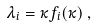<formula> <loc_0><loc_0><loc_500><loc_500>\lambda _ { i } = \kappa f _ { i } ( \kappa ) \, ,</formula> 